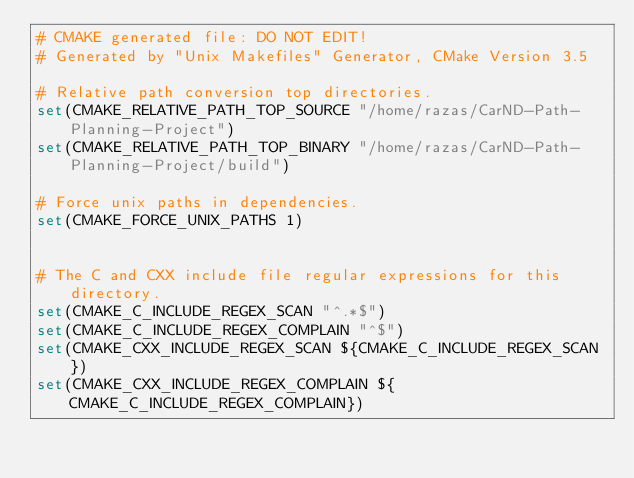Convert code to text. <code><loc_0><loc_0><loc_500><loc_500><_CMake_># CMAKE generated file: DO NOT EDIT!
# Generated by "Unix Makefiles" Generator, CMake Version 3.5

# Relative path conversion top directories.
set(CMAKE_RELATIVE_PATH_TOP_SOURCE "/home/razas/CarND-Path-Planning-Project")
set(CMAKE_RELATIVE_PATH_TOP_BINARY "/home/razas/CarND-Path-Planning-Project/build")

# Force unix paths in dependencies.
set(CMAKE_FORCE_UNIX_PATHS 1)


# The C and CXX include file regular expressions for this directory.
set(CMAKE_C_INCLUDE_REGEX_SCAN "^.*$")
set(CMAKE_C_INCLUDE_REGEX_COMPLAIN "^$")
set(CMAKE_CXX_INCLUDE_REGEX_SCAN ${CMAKE_C_INCLUDE_REGEX_SCAN})
set(CMAKE_CXX_INCLUDE_REGEX_COMPLAIN ${CMAKE_C_INCLUDE_REGEX_COMPLAIN})
</code> 